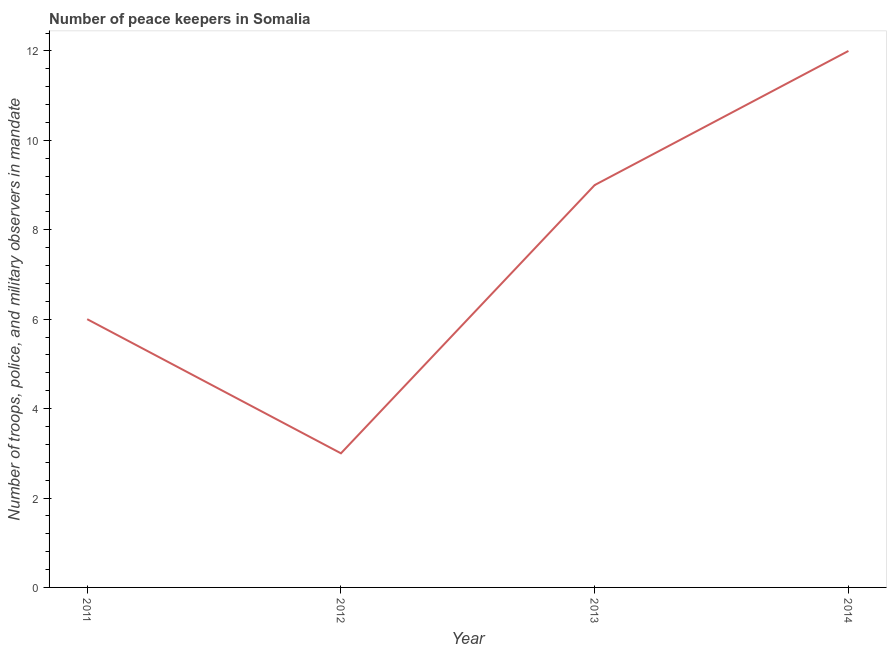What is the number of peace keepers in 2012?
Your answer should be very brief. 3. Across all years, what is the maximum number of peace keepers?
Provide a short and direct response. 12. Across all years, what is the minimum number of peace keepers?
Make the answer very short. 3. What is the sum of the number of peace keepers?
Make the answer very short. 30. What is the difference between the number of peace keepers in 2011 and 2014?
Provide a succinct answer. -6. What is the average number of peace keepers per year?
Give a very brief answer. 7.5. What is the median number of peace keepers?
Offer a very short reply. 7.5. Is the number of peace keepers in 2012 less than that in 2014?
Provide a short and direct response. Yes. What is the difference between the highest and the second highest number of peace keepers?
Ensure brevity in your answer.  3. What is the difference between the highest and the lowest number of peace keepers?
Provide a short and direct response. 9. In how many years, is the number of peace keepers greater than the average number of peace keepers taken over all years?
Ensure brevity in your answer.  2. How many lines are there?
Ensure brevity in your answer.  1. What is the title of the graph?
Provide a succinct answer. Number of peace keepers in Somalia. What is the label or title of the Y-axis?
Make the answer very short. Number of troops, police, and military observers in mandate. What is the Number of troops, police, and military observers in mandate in 2012?
Offer a very short reply. 3. What is the Number of troops, police, and military observers in mandate in 2013?
Keep it short and to the point. 9. What is the Number of troops, police, and military observers in mandate in 2014?
Ensure brevity in your answer.  12. What is the difference between the Number of troops, police, and military observers in mandate in 2012 and 2013?
Provide a succinct answer. -6. What is the difference between the Number of troops, police, and military observers in mandate in 2012 and 2014?
Your answer should be very brief. -9. What is the difference between the Number of troops, police, and military observers in mandate in 2013 and 2014?
Your answer should be very brief. -3. What is the ratio of the Number of troops, police, and military observers in mandate in 2011 to that in 2012?
Ensure brevity in your answer.  2. What is the ratio of the Number of troops, police, and military observers in mandate in 2011 to that in 2013?
Your answer should be very brief. 0.67. What is the ratio of the Number of troops, police, and military observers in mandate in 2011 to that in 2014?
Your answer should be very brief. 0.5. What is the ratio of the Number of troops, police, and military observers in mandate in 2012 to that in 2013?
Your response must be concise. 0.33. What is the ratio of the Number of troops, police, and military observers in mandate in 2012 to that in 2014?
Keep it short and to the point. 0.25. 